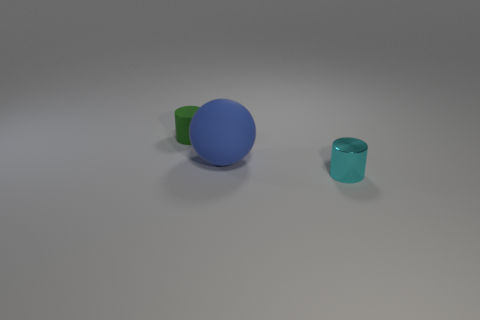What color is the rubber thing behind the big blue sphere that is behind the tiny metal thing?
Offer a terse response. Green. Is there a green cylinder right of the small thing that is behind the cylinder in front of the big matte sphere?
Provide a succinct answer. No. What color is the cylinder that is made of the same material as the big object?
Provide a succinct answer. Green. How many large blue spheres are made of the same material as the big thing?
Offer a terse response. 0. Does the blue sphere have the same material as the cylinder behind the blue object?
Provide a succinct answer. Yes. What number of objects are cylinders to the left of the big blue matte ball or tiny yellow rubber objects?
Your answer should be very brief. 1. There is a matte thing that is behind the rubber object that is in front of the green object behind the cyan object; what is its size?
Your response must be concise. Small. Is there any other thing that has the same shape as the blue object?
Your response must be concise. No. What size is the cylinder behind the object that is on the right side of the blue ball?
Offer a terse response. Small. What number of large things are either gray matte things or blue spheres?
Offer a very short reply. 1. 